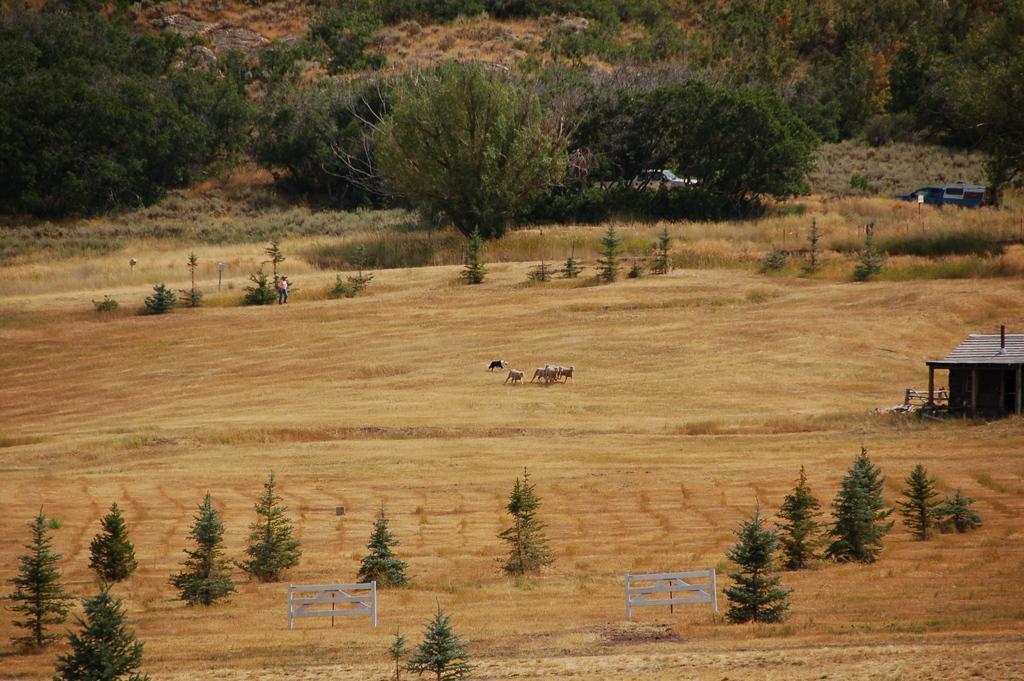Describe this image in one or two sentences. In this picture there are animals in the middle of the image and there is a person walking. On the right side of the image there is a building. At the back there are vehicles and there are trees. In the foreground there are benches. At the bottom there is mud. 